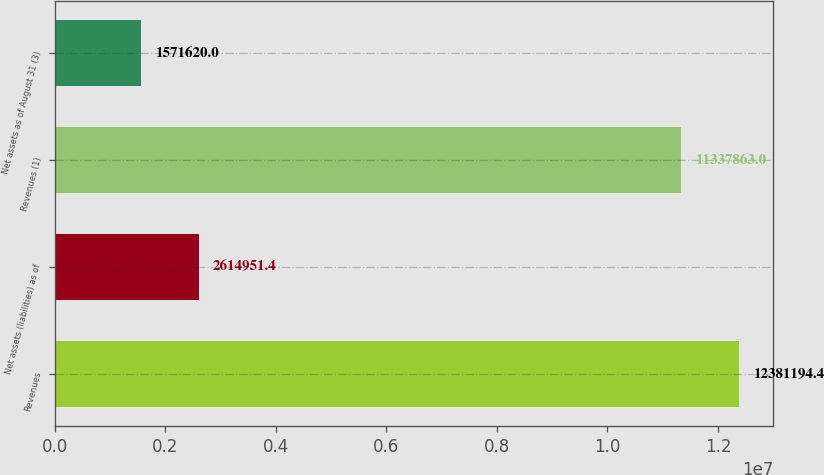Convert chart to OTSL. <chart><loc_0><loc_0><loc_500><loc_500><bar_chart><fcel>Revenues<fcel>Net assets (liabilities) as of<fcel>Revenues (1)<fcel>Net assets as of August 31 (3)<nl><fcel>1.23812e+07<fcel>2.61495e+06<fcel>1.13379e+07<fcel>1.57162e+06<nl></chart> 